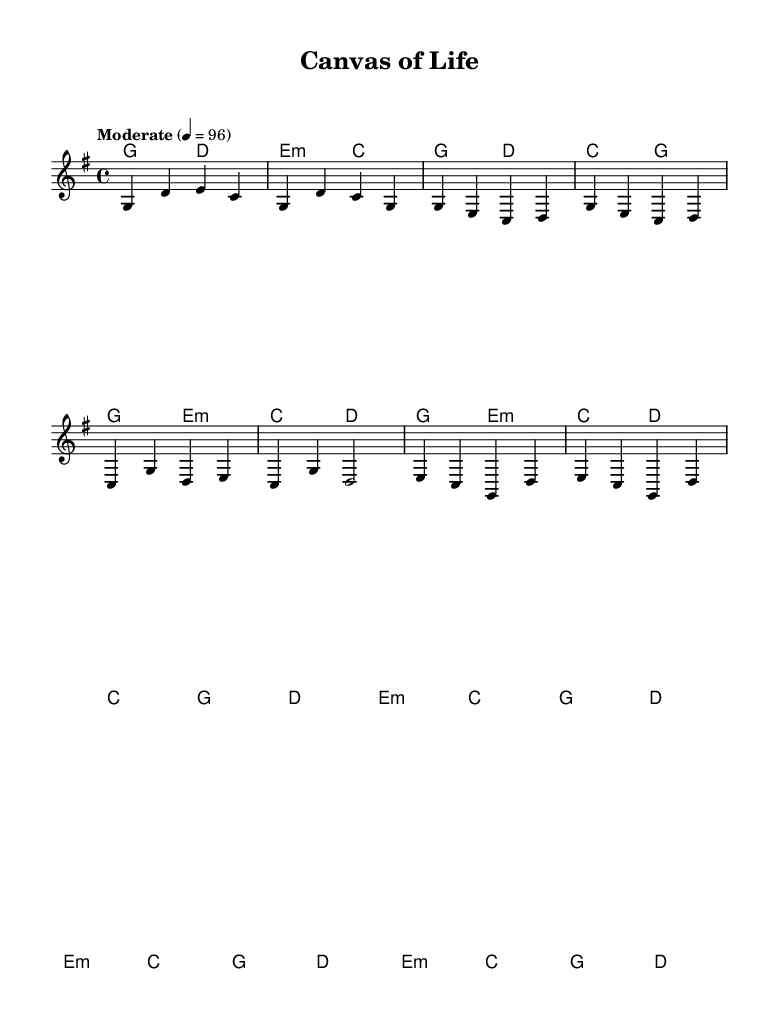What is the key signature of this music? The key signature shown is G major, which has one sharp (F#) in it.
Answer: G major What is the time signature of this piece? The time signature is indicated as 4/4, meaning there are four beats in each measure and the quarter note gets one beat.
Answer: 4/4 What is the tempo marking for this song? The tempo marking is "Moderate" with a beat of 96, indicating a moderate pace for the music.
Answer: Moderate Which section starts with a G chord? The intro begins with a G chord, as indicated at the beginning of the harmonies section.
Answer: Intro How many measures are in the chorus section presented? The chorus section consists of four measures as shown in the melody and harmonies. Counting the measures precisely confirms this.
Answer: 4 What is the melodic note that follows the first G chord in the intro? The melodic note following the first G chord in the intro is D, as seen in the melody part.
Answer: D What type of chord is present in the bridge section? The bridge features an E minor chord, indicated by the symbols in the harmonies part.
Answer: E minor 